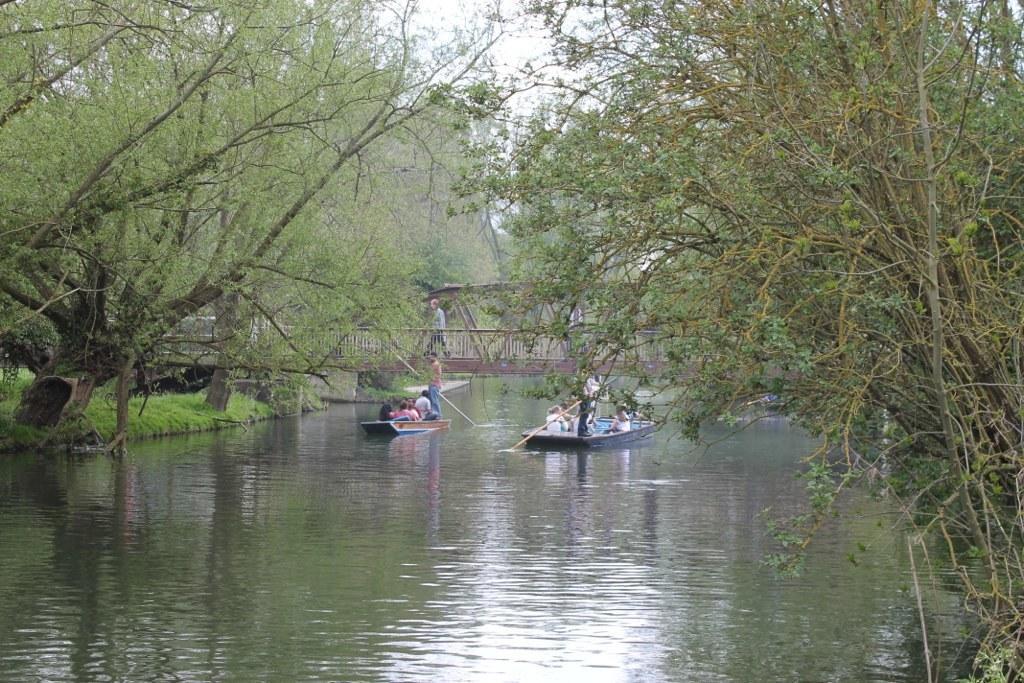Could you give a brief overview of what you see in this image? In this image we can see the people boating on the surface of the water. We can also see the trees, grass and also the sky. We can see a person walking on the bridge. 